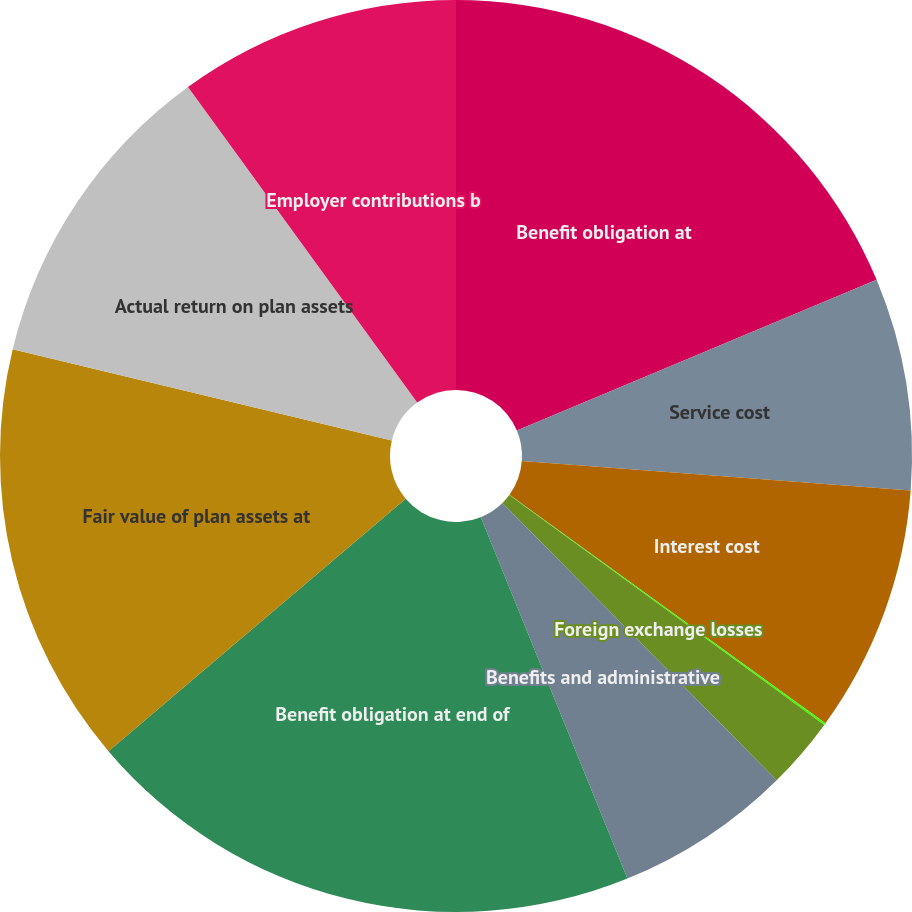<chart> <loc_0><loc_0><loc_500><loc_500><pie_chart><fcel>Benefit obligation at<fcel>Service cost<fcel>Interest cost<fcel>Actuarial losses (gains)<fcel>Foreign exchange losses<fcel>Benefits and administrative<fcel>Benefit obligation at end of<fcel>Fair value of plan assets at<fcel>Actual return on plan assets<fcel>Employer contributions b<nl><fcel>18.69%<fcel>7.52%<fcel>8.76%<fcel>0.07%<fcel>2.55%<fcel>6.28%<fcel>19.93%<fcel>14.97%<fcel>11.24%<fcel>10.0%<nl></chart> 